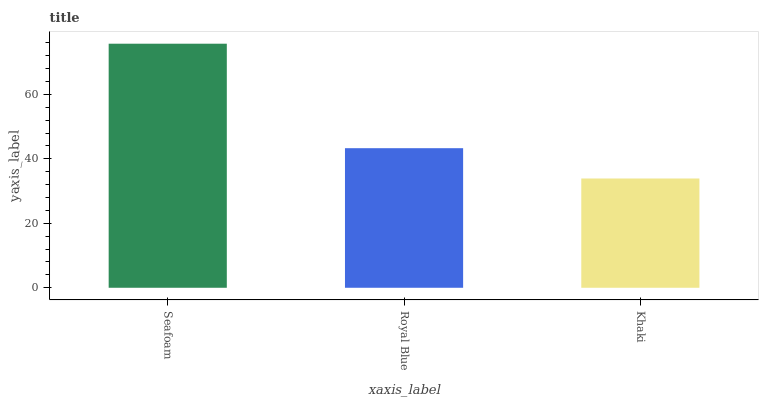Is Khaki the minimum?
Answer yes or no. Yes. Is Seafoam the maximum?
Answer yes or no. Yes. Is Royal Blue the minimum?
Answer yes or no. No. Is Royal Blue the maximum?
Answer yes or no. No. Is Seafoam greater than Royal Blue?
Answer yes or no. Yes. Is Royal Blue less than Seafoam?
Answer yes or no. Yes. Is Royal Blue greater than Seafoam?
Answer yes or no. No. Is Seafoam less than Royal Blue?
Answer yes or no. No. Is Royal Blue the high median?
Answer yes or no. Yes. Is Royal Blue the low median?
Answer yes or no. Yes. Is Seafoam the high median?
Answer yes or no. No. Is Seafoam the low median?
Answer yes or no. No. 